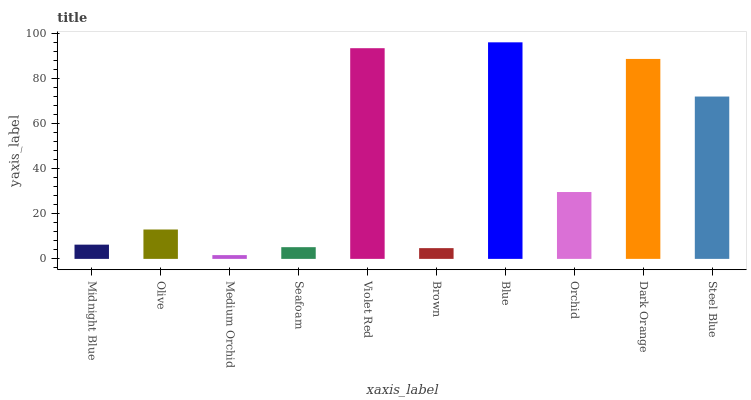Is Medium Orchid the minimum?
Answer yes or no. Yes. Is Blue the maximum?
Answer yes or no. Yes. Is Olive the minimum?
Answer yes or no. No. Is Olive the maximum?
Answer yes or no. No. Is Olive greater than Midnight Blue?
Answer yes or no. Yes. Is Midnight Blue less than Olive?
Answer yes or no. Yes. Is Midnight Blue greater than Olive?
Answer yes or no. No. Is Olive less than Midnight Blue?
Answer yes or no. No. Is Orchid the high median?
Answer yes or no. Yes. Is Olive the low median?
Answer yes or no. Yes. Is Seafoam the high median?
Answer yes or no. No. Is Midnight Blue the low median?
Answer yes or no. No. 